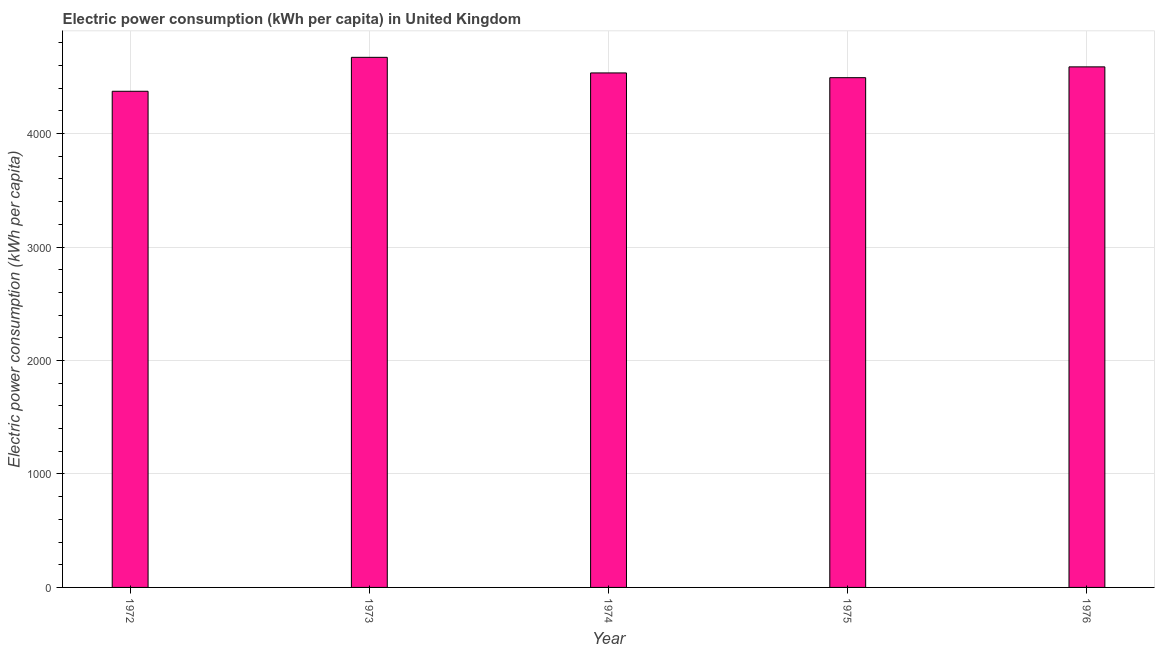Does the graph contain any zero values?
Keep it short and to the point. No. What is the title of the graph?
Give a very brief answer. Electric power consumption (kWh per capita) in United Kingdom. What is the label or title of the Y-axis?
Your answer should be very brief. Electric power consumption (kWh per capita). What is the electric power consumption in 1973?
Provide a succinct answer. 4671.72. Across all years, what is the maximum electric power consumption?
Keep it short and to the point. 4671.72. Across all years, what is the minimum electric power consumption?
Ensure brevity in your answer.  4372.64. In which year was the electric power consumption minimum?
Provide a succinct answer. 1972. What is the sum of the electric power consumption?
Offer a very short reply. 2.27e+04. What is the difference between the electric power consumption in 1975 and 1976?
Your answer should be very brief. -95.27. What is the average electric power consumption per year?
Make the answer very short. 4531.74. What is the median electric power consumption?
Ensure brevity in your answer.  4534.25. In how many years, is the electric power consumption greater than 2400 kWh per capita?
Provide a succinct answer. 5. What is the ratio of the electric power consumption in 1973 to that in 1975?
Ensure brevity in your answer.  1.04. Is the electric power consumption in 1974 less than that in 1975?
Offer a very short reply. No. What is the difference between the highest and the second highest electric power consumption?
Offer a very short reply. 84.03. Is the sum of the electric power consumption in 1972 and 1976 greater than the maximum electric power consumption across all years?
Offer a terse response. Yes. What is the difference between the highest and the lowest electric power consumption?
Ensure brevity in your answer.  299.08. What is the difference between two consecutive major ticks on the Y-axis?
Your answer should be very brief. 1000. What is the Electric power consumption (kWh per capita) in 1972?
Make the answer very short. 4372.64. What is the Electric power consumption (kWh per capita) of 1973?
Provide a succinct answer. 4671.72. What is the Electric power consumption (kWh per capita) in 1974?
Make the answer very short. 4534.25. What is the Electric power consumption (kWh per capita) of 1975?
Make the answer very short. 4492.42. What is the Electric power consumption (kWh per capita) of 1976?
Provide a succinct answer. 4587.69. What is the difference between the Electric power consumption (kWh per capita) in 1972 and 1973?
Offer a very short reply. -299.08. What is the difference between the Electric power consumption (kWh per capita) in 1972 and 1974?
Make the answer very short. -161.62. What is the difference between the Electric power consumption (kWh per capita) in 1972 and 1975?
Offer a terse response. -119.78. What is the difference between the Electric power consumption (kWh per capita) in 1972 and 1976?
Offer a terse response. -215.05. What is the difference between the Electric power consumption (kWh per capita) in 1973 and 1974?
Your answer should be very brief. 137.46. What is the difference between the Electric power consumption (kWh per capita) in 1973 and 1975?
Give a very brief answer. 179.3. What is the difference between the Electric power consumption (kWh per capita) in 1973 and 1976?
Offer a terse response. 84.03. What is the difference between the Electric power consumption (kWh per capita) in 1974 and 1975?
Your answer should be very brief. 41.83. What is the difference between the Electric power consumption (kWh per capita) in 1974 and 1976?
Your response must be concise. -53.43. What is the difference between the Electric power consumption (kWh per capita) in 1975 and 1976?
Provide a succinct answer. -95.27. What is the ratio of the Electric power consumption (kWh per capita) in 1972 to that in 1973?
Ensure brevity in your answer.  0.94. What is the ratio of the Electric power consumption (kWh per capita) in 1972 to that in 1974?
Your answer should be very brief. 0.96. What is the ratio of the Electric power consumption (kWh per capita) in 1972 to that in 1976?
Give a very brief answer. 0.95. What is the ratio of the Electric power consumption (kWh per capita) in 1973 to that in 1974?
Offer a very short reply. 1.03. What is the ratio of the Electric power consumption (kWh per capita) in 1973 to that in 1975?
Give a very brief answer. 1.04. What is the ratio of the Electric power consumption (kWh per capita) in 1973 to that in 1976?
Offer a very short reply. 1.02. What is the ratio of the Electric power consumption (kWh per capita) in 1974 to that in 1975?
Your answer should be compact. 1.01. What is the ratio of the Electric power consumption (kWh per capita) in 1975 to that in 1976?
Your answer should be very brief. 0.98. 